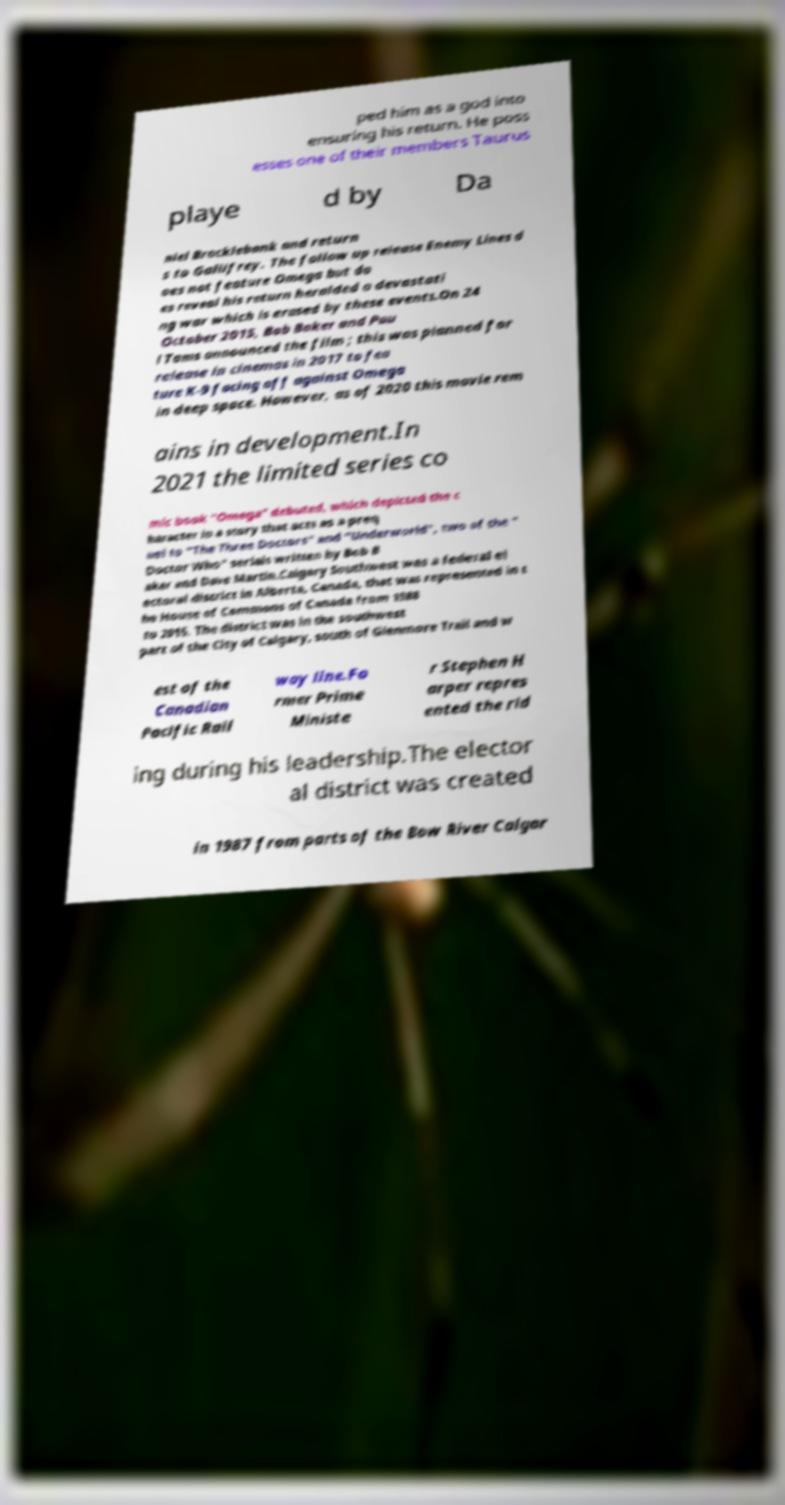Can you accurately transcribe the text from the provided image for me? ped him as a god into ensuring his return. He poss esses one of their members Taurus playe d by Da niel Brocklebank and return s to Gallifrey. The follow up release Enemy Lines d oes not feature Omega but do es reveal his return heralded a devastati ng war which is erased by these events.On 24 October 2015, Bob Baker and Pau l Tams announced the film ; this was planned for release in cinemas in 2017 to fea ture K-9 facing off against Omega in deep space. However, as of 2020 this movie rem ains in development.In 2021 the limited series co mic book "Omega" debuted, which depicted the c haracter in a story that acts as a preq uel to "The Three Doctors" and "Underworld", two of the " Doctor Who" serials written by Bob B aker and Dave Martin.Calgary Southwest was a federal el ectoral district in Alberta, Canada, that was represented in t he House of Commons of Canada from 1988 to 2015. The district was in the southwest part of the City of Calgary, south of Glenmore Trail and w est of the Canadian Pacific Rail way line.Fo rmer Prime Ministe r Stephen H arper repres ented the rid ing during his leadership.The elector al district was created in 1987 from parts of the Bow River Calgar 